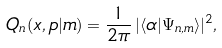<formula> <loc_0><loc_0><loc_500><loc_500>Q _ { n } ( x , p | m ) = \frac { 1 } { 2 \pi } \, | \langle \alpha | \Psi _ { n , m } \rangle | ^ { 2 } ,</formula> 